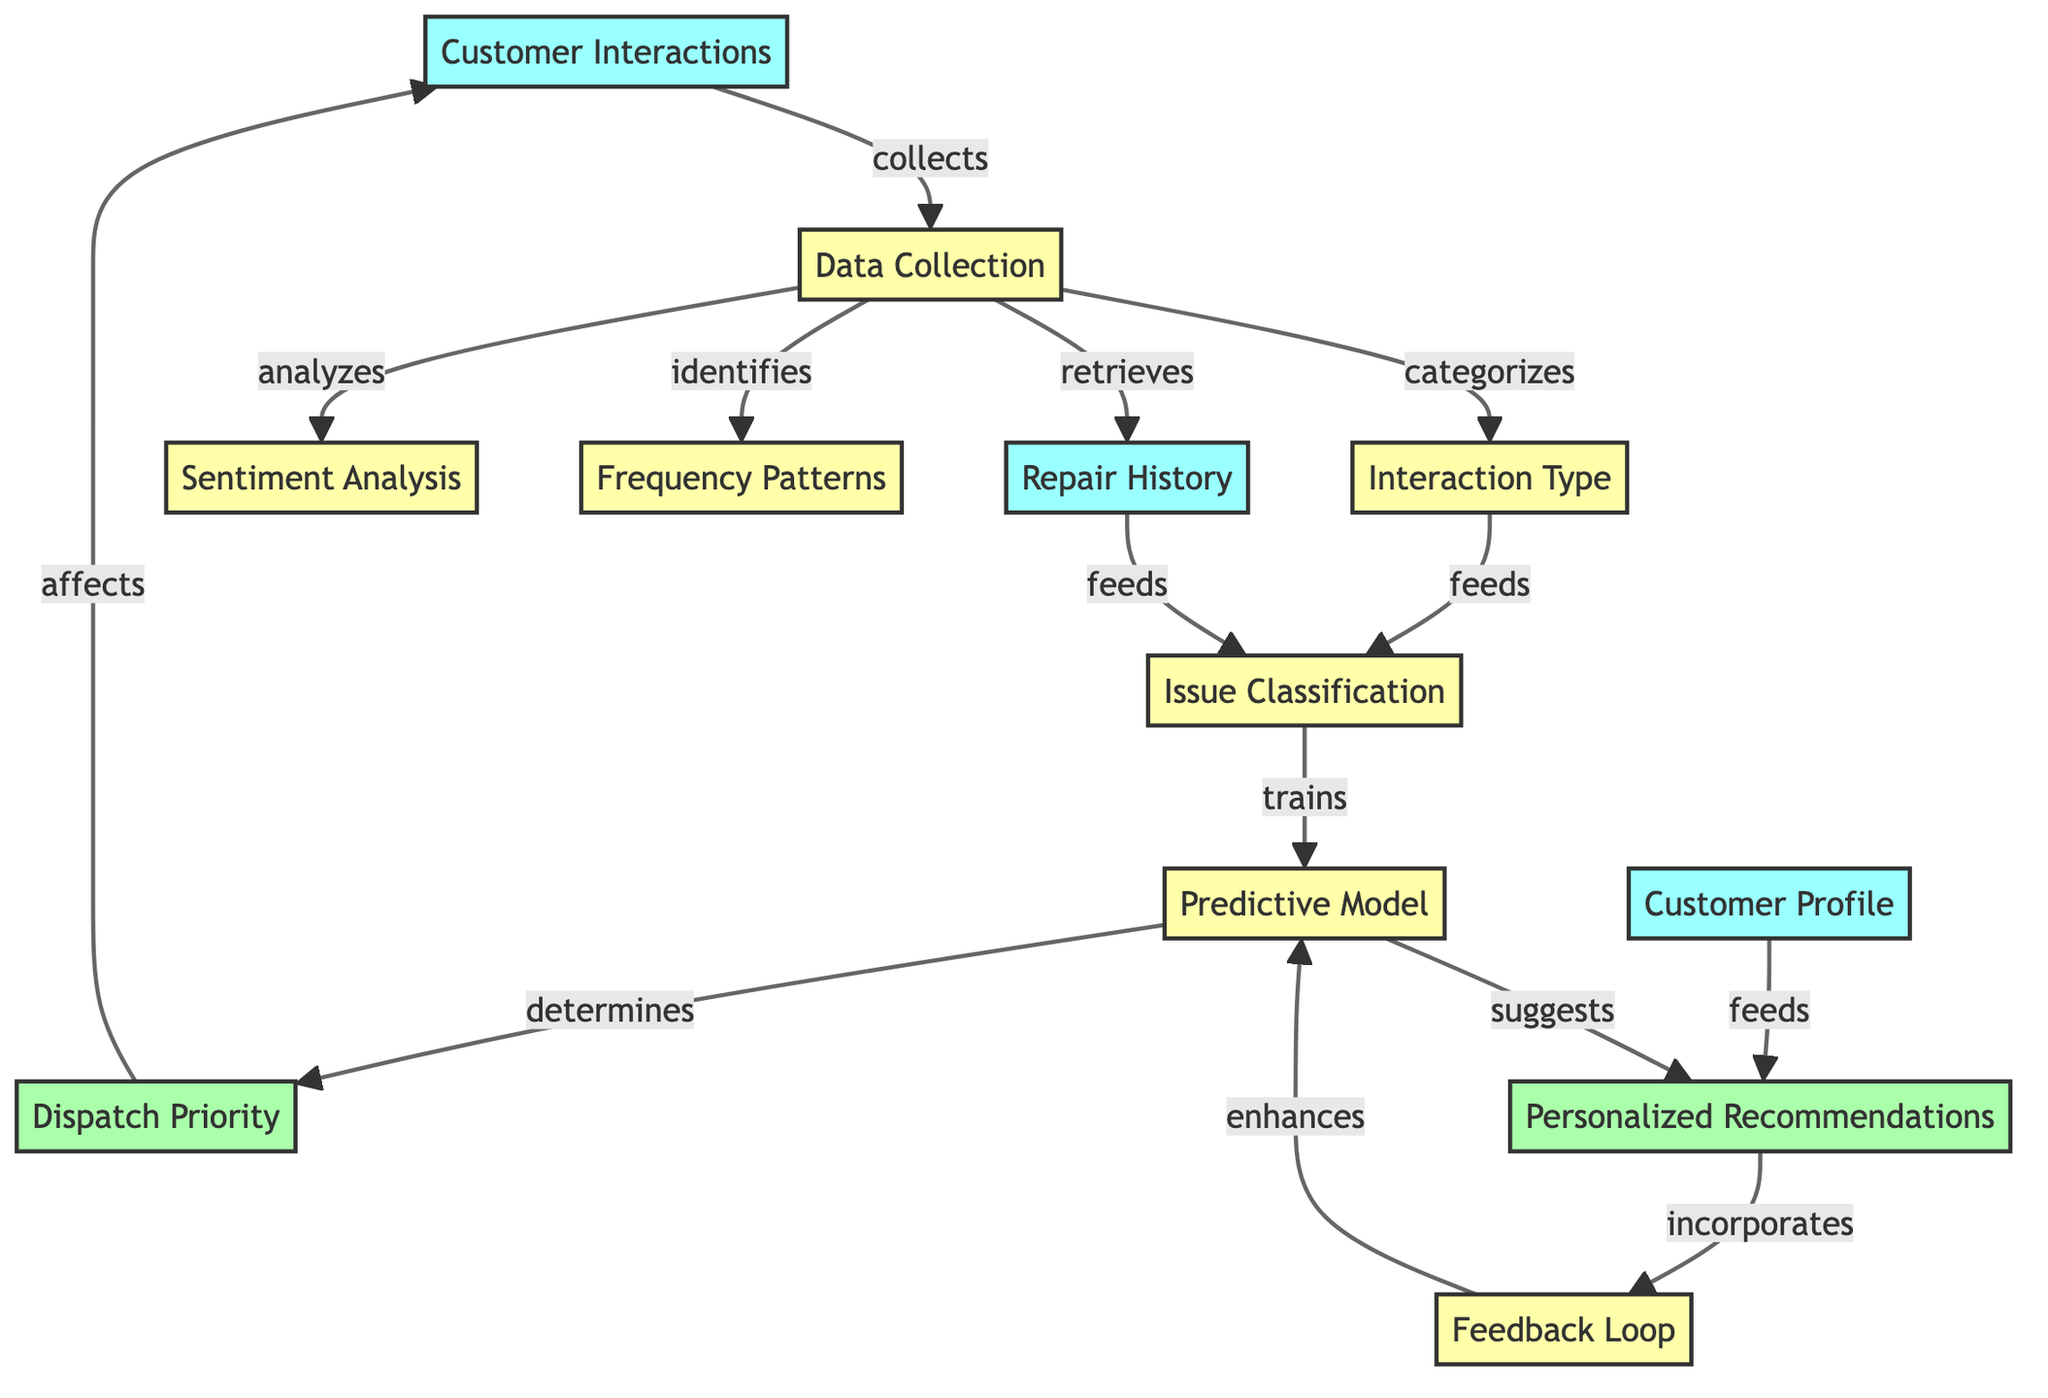What is the first step in the diagram? The first step in the diagram is "Customer Interactions," which indicates the initial gathering of data before any processing can take place.
Answer: Customer Interactions How many process nodes are there in the diagram? Upon reviewing the diagram, the process nodes include "Data Collection," "Interaction Type," "Sentiment Analysis," "Frequency Patterns," "Issue Classification," "Predictive Model," "Feedback Loop," and "Dispatch Priority," totaling seven process nodes.
Answer: Seven What does the "Data Collection" node do? The "Data Collection" node is responsible for collecting and categorizing data about customer interactions, analyzing sentiment, identifying frequency patterns, and retrieving repair history data.
Answer: Collects data Which two nodes feed into "Issue Classification"? The "Interaction Type" and "Repair History" nodes provide the necessary input to the "Issue Classification" node, assisting in the classification of issues based on customer interactions.
Answer: Interaction Type, Repair History What is the output of the "Predictive Model"? The "Predictive Model" outputs both "Dispatch Priority" and "Personalized Recommendations," making predictions based on the processed inputs from prior nodes.
Answer: Dispatch Priority, Personalized Recommendations How does the "Feedback Loop" affect the "Predictive Model"? The "Feedback Loop" enhances the "Predictive Model" by incorporating feedback from the "Personalized Recommendations," which in turn helps improve the accuracy of predictions.
Answer: Enhances What is indicated by the arrow from "Personalized Recommendations" to "Customer Interactions"? The arrow signifies that the "Personalized Recommendations" directly influence and affect how customer interactions are managed based on tailored suggestions.
Answer: Affects Which node retrieves data to be classified in "Issue Classification"? "Repair History" retrieves data necessary for feeding into the "Issue Classification" node, providing context about past repairs associated with the customer.
Answer: Repair History 